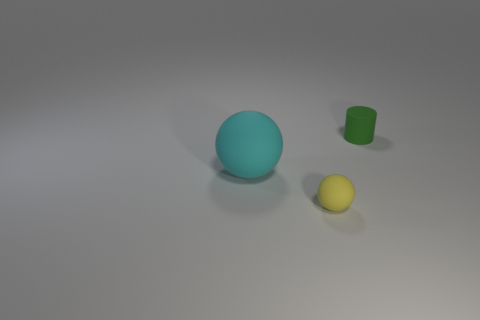Add 1 small purple metallic balls. How many objects exist? 4 Subtract all balls. How many objects are left? 1 Add 1 small green cylinders. How many small green cylinders exist? 2 Subtract 0 red blocks. How many objects are left? 3 Subtract all yellow things. Subtract all green cylinders. How many objects are left? 1 Add 2 large cyan matte things. How many large cyan matte things are left? 3 